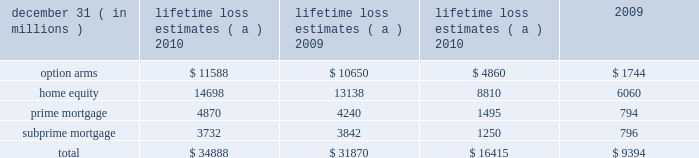Management 2019s discussion and analysis 132 jpmorgan chase & co./2010 annual report unpaid principal balance due to negative amortization of option arms was $ 24 million and $ 78 million at december 31 , 2010 and 2009 , respectively .
The firm estimates the following balances of option arm loans will experience a recast that results in a payment increase : $ 72 million in 2011 , $ 241 million in 2012 and $ 784 million in 2013 .
The firm did not originate option arms and new originations of option arms were discontinued by washington mutual prior to the date of jpmorgan chase 2019s acquisition of its banking operations .
Subprime mortgages at december 31 , 2010 were $ 11.3 billion , compared with $ 12.5 billion at december 31 , 2009 .
The decrease was due to paydowns and charge-offs on delinquent loans , partially offset by the addition of loans as a result of the adoption of the accounting guidance related to vies .
Late-stage delinquencies remained elevated but continued to improve , albeit at a slower rate during the second half of the year , while early-stage delinquencies stabilized at an elevated level during this period .
Nonaccrual loans improved largely as a result of the improvement in late-stage delinquencies .
Charge-offs reflected modest improvement .
Auto : auto loans at december 31 , 2010 , were $ 48.4 billion , compared with $ 46.0 billion at december 31 , 2009 .
Delinquent and nonaccrual loans have decreased .
In addition , net charge-offs have declined 52% ( 52 % ) from the prior year .
Provision expense de- creased due to favorable loss severity as a result of a strong used- car market nationwide and reduced loss frequency due to the tightening of underwriting criteria in earlier periods .
The auto loan portfolio reflected a high concentration of prime quality credits .
Business banking : business banking loans at december 31 , 2010 , were $ 16.8 billion , compared with $ 17.0 billion at december 31 , 2009 .
The decrease was primarily a result of run-off of the washington mutual portfolio and charge-offs on delinquent loans .
These loans primarily include loans which are highly collateralized , often with personal loan guarantees .
Nonaccrual loans continued to remain elevated .
After having increased during the first half of 2010 , nonaccrual loans as of december 31 , 2010 , declined to year-end 2009 levels .
Student and other : student and other loans at december 31 , 2010 , including loans held-for-sale , were $ 15.3 billion , compared with $ 16.4 billion at december 31 , 2009 .
Other loans primarily include other secured and unsecured consumer loans .
Delinquencies reflected some stabilization in the second half of 2010 , but remained elevated .
Charge-offs during 2010 remained relatively flat with 2009 levels reflecting the impact of elevated unemployment levels .
Purchased credit-impaired loans : pci loans at december 31 , 2010 , were $ 72.8 billion compared with $ 81.2 billion at december 31 , 2009 .
This portfolio represents loans acquired in the washing- ton mutual transaction that were recorded at fair value at the time of acquisition .
That fair value included an estimate of credit losses expected to be realized over the remaining lives of the loans , and therefore no allowance for loan losses was recorded for these loans as of the acquisition date .
The firm regularly updates the amount of principal and interest cash flows expected to be collected for these loans .
Probable decreases in expected loan principal cash flows would trigger the recognition of impairment through the provision for loan losses .
Probable and significant increases in expected cash flows ( e.g. , decreased principal credit losses , the net benefit of modifications ) would first reverse any previously recorded allowance for loan losses , with any remaining increase in the expected cash flows recognized prospectively in interest income over the remaining estimated lives of the underlying loans .
During 2010 , management concluded as part of the firm 2019s regular assessment of the pci pools that it was probable that higher expected principal credit losses would result in a decrease in expected cash flows .
Accordingly , the firm recognized an aggregate $ 3.4 billion impairment related to the home equity , prime mortgage , option arm and subprime mortgage pci portfolios .
As a result of this impairment , the firm 2019s allowance for loan losses for the home equity , prime mortgage , option arm and subprime mortgage pci portfolios was $ 1.6 billion , $ 1.8 billion , $ 1.5 billion and $ 98 million , respectively , at december 31 , 2010 , compared with an allowance for loan losses of $ 1.1 billion and $ 491 million for the prime mortgage and option arm pci portfolios , respectively , at december 31 , 2009 .
Approximately 39% ( 39 % ) of the option arm borrowers were delinquent , 5% ( 5 % ) were making interest-only or negatively amortizing payments , and 56% ( 56 % ) were making amortizing payments .
Approximately 50% ( 50 % ) of current borrowers are subject to risk of payment shock due to future payment recast ; substantially all of the remaining loans have been modified to a fixed rate fully amortizing loan .
The cumulative amount of unpaid interest added to the unpaid principal balance of the option arm pci pool was $ 1.4 billion and $ 1.9 billion at de- cember 31 , 2010 and 2009 , respectively .
The firm estimates the following balances of option arm pci loans will experience a recast that results in a payment increase : $ 1.2 billion in 2011 , $ 2.7 billion in 2012 and $ 508 million in 2013 .
The table provides a summary of lifetime loss estimates included in both the nonaccretable difference and the allowance for loan losses .
Principal charge-offs will not be recorded on these pools until the nonaccretable difference has been fully depleted .
Lifetime loss estimates ( a ) ltd liquidation losses ( b ) .
( a ) includes the original nonaccretable difference established in purchase accounting of $ 30.5 billion for principal losses only .
The remaining nonaccretable difference for principal losses only was $ 14.1 billion and $ 21.1 billion at december 31 , 2010 and 2009 , respectively .
All probable increases in principal losses and foregone interest subsequent to the purchase date are reflected in the allowance for loan losses .
( b ) life-to-date ( 201cltd 201d ) liquidation losses represent realization of loss upon loan resolution. .
What was the ratio of the business banking loans at december 31 , 2010 compared with $ 17.0 billion at december 31 , 2009 .? 
Computations: (16.8 / 17.0)
Answer: 0.98824. 